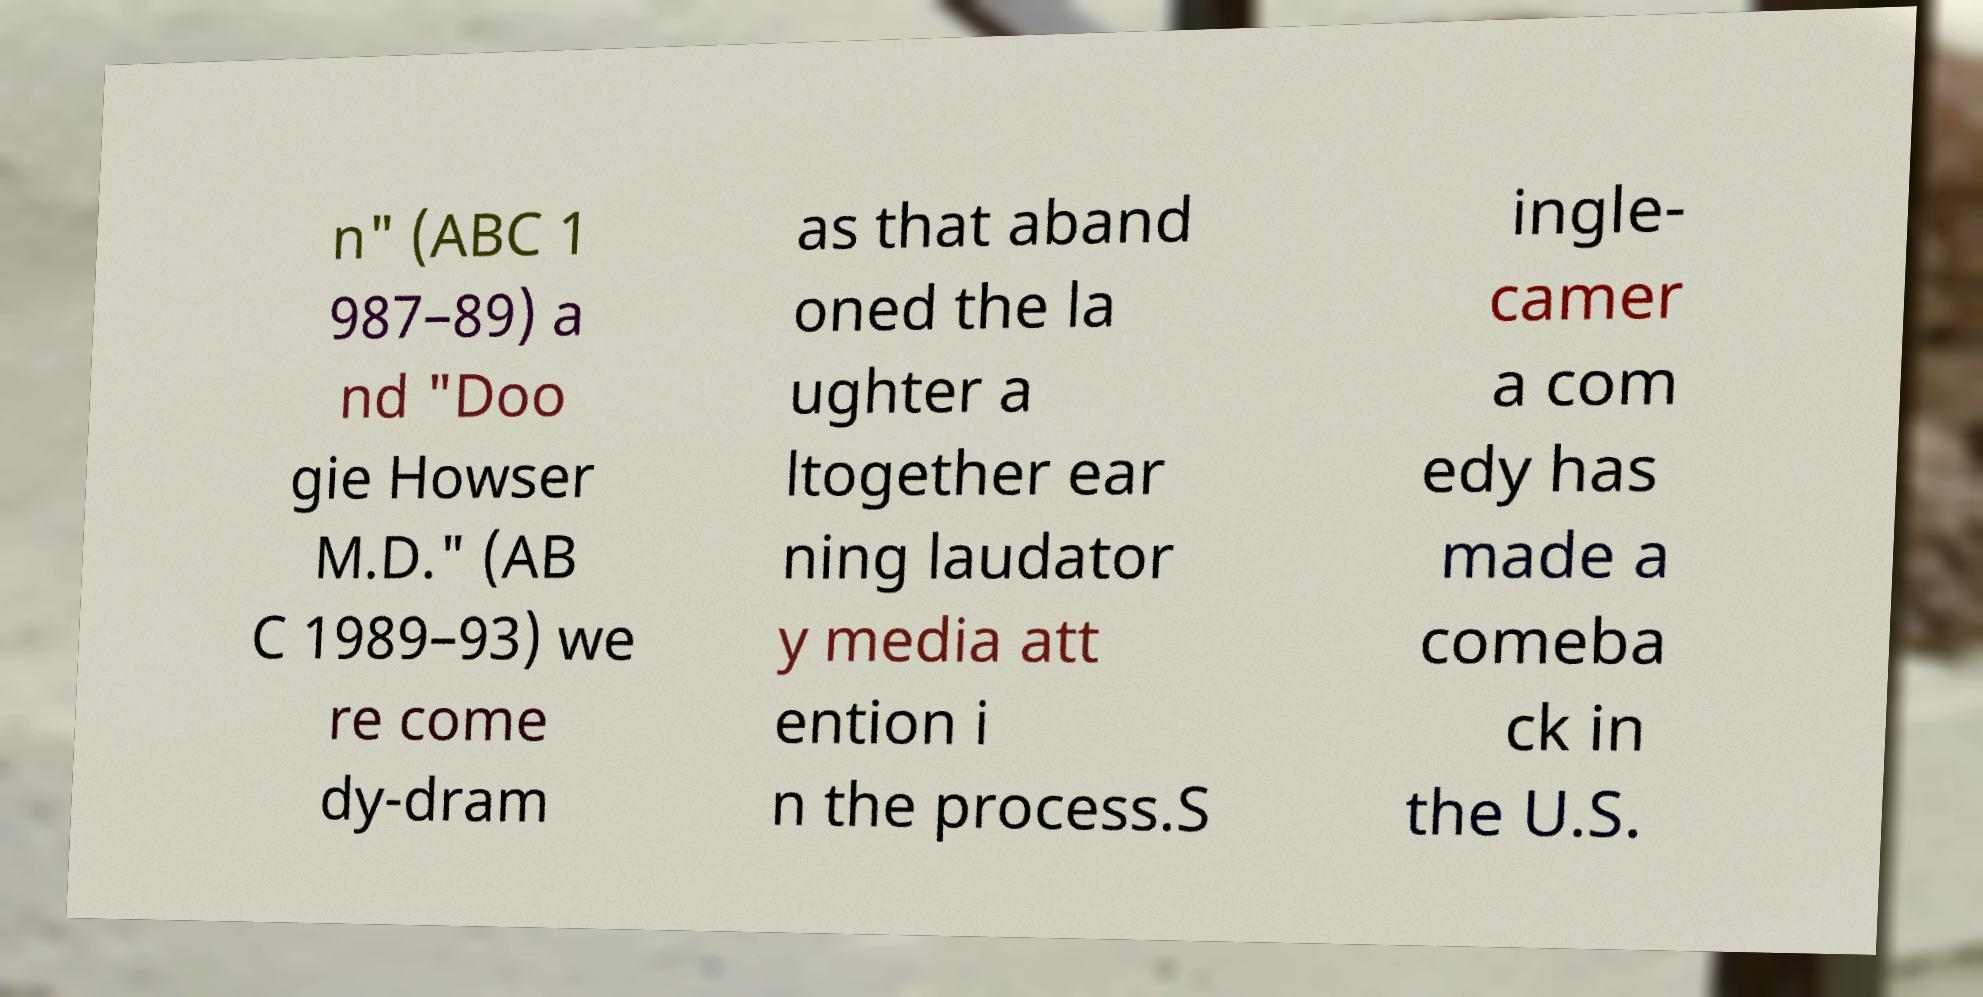Please read and relay the text visible in this image. What does it say? n" (ABC 1 987–89) a nd "Doo gie Howser M.D." (AB C 1989–93) we re come dy-dram as that aband oned the la ughter a ltogether ear ning laudator y media att ention i n the process.S ingle- camer a com edy has made a comeba ck in the U.S. 